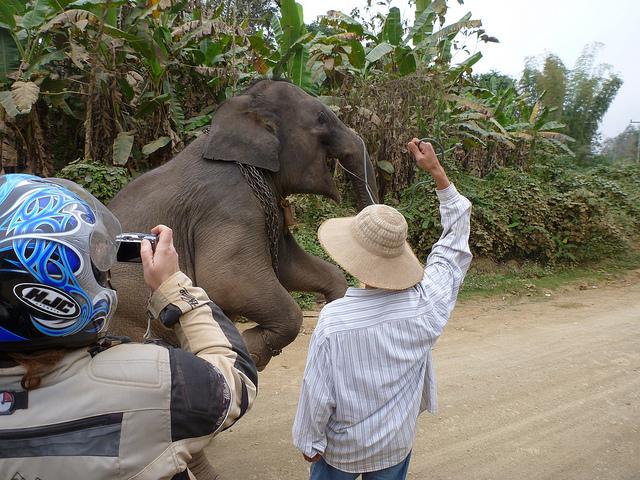What has the man placed around the animal's neck?
Quick response, please. Chain. Are both peoples heads covered?
Short answer required. Yes. Is this an African elephant?
Answer briefly. No. Which foot does the man have forward?
Quick response, please. Left. What is on the man's head?
Concise answer only. Hat. 